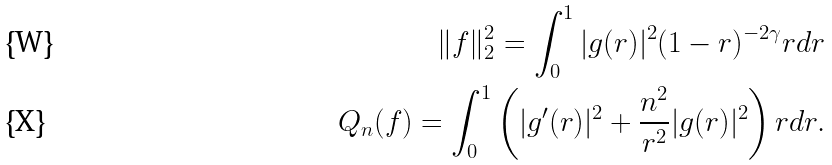Convert formula to latex. <formula><loc_0><loc_0><loc_500><loc_500>\| f \| _ { 2 } ^ { 2 } = \int _ { 0 } ^ { 1 } | g ( r ) | ^ { 2 } ( 1 - r ) ^ { - 2 \gamma } r d r \\ Q _ { n } ( f ) = \int _ { 0 } ^ { 1 } \left ( | g ^ { \prime } ( r ) | ^ { 2 } + \frac { n ^ { 2 } } { r ^ { 2 } } | g ( r ) | ^ { 2 } \right ) r d r .</formula> 